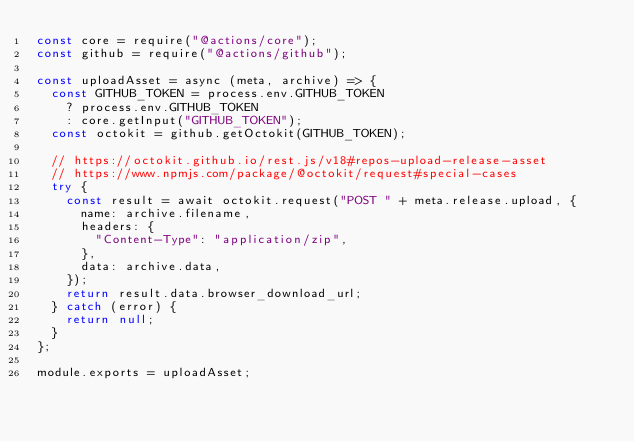Convert code to text. <code><loc_0><loc_0><loc_500><loc_500><_JavaScript_>const core = require("@actions/core");
const github = require("@actions/github");

const uploadAsset = async (meta, archive) => {
  const GITHUB_TOKEN = process.env.GITHUB_TOKEN
    ? process.env.GITHUB_TOKEN
    : core.getInput("GITHUB_TOKEN");
  const octokit = github.getOctokit(GITHUB_TOKEN);

  // https://octokit.github.io/rest.js/v18#repos-upload-release-asset
  // https://www.npmjs.com/package/@octokit/request#special-cases
  try {
    const result = await octokit.request("POST " + meta.release.upload, {
      name: archive.filename,
      headers: {
        "Content-Type": "application/zip",
      },
      data: archive.data,
    });
    return result.data.browser_download_url;
  } catch (error) {
    return null;
  }
};

module.exports = uploadAsset;
</code> 